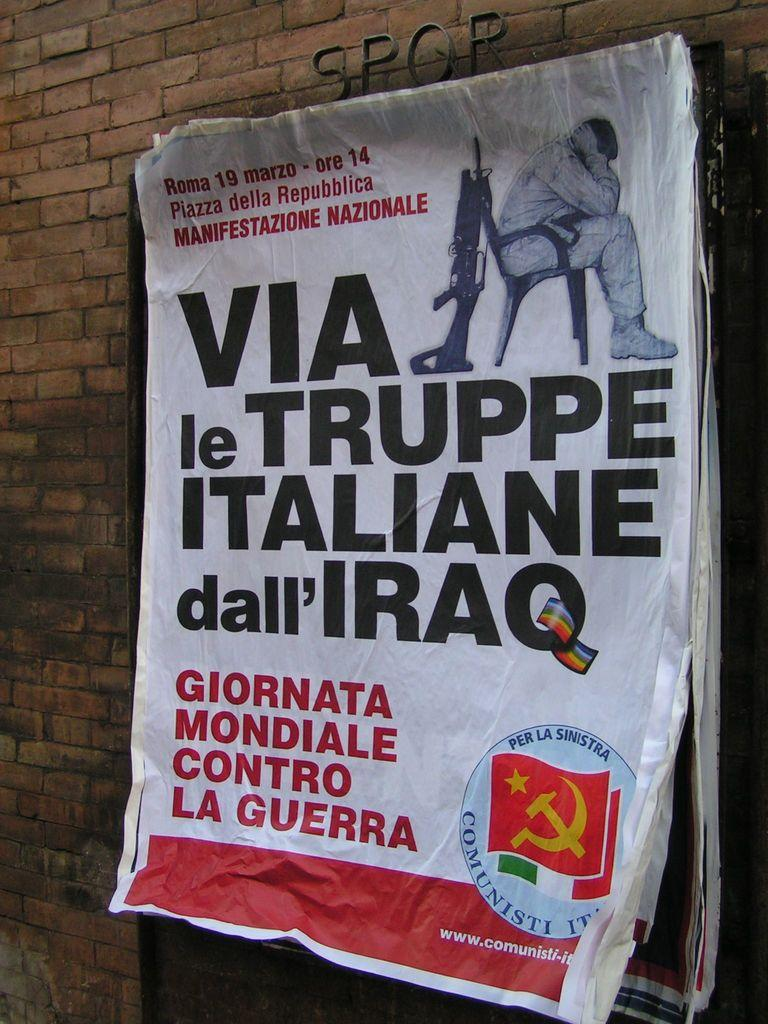<image>
Describe the image concisely. A crumpled magazine with a soldier sitting in a chair with a rifle propped against it called Manifestazione Nazionale. 